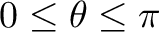Convert formula to latex. <formula><loc_0><loc_0><loc_500><loc_500>0 \leq \theta \leq \pi</formula> 